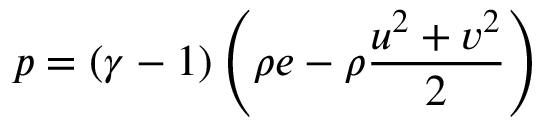Convert formula to latex. <formula><loc_0><loc_0><loc_500><loc_500>p = ( \gamma - 1 ) \left ( \rho e - \rho \frac { u ^ { 2 } + v ^ { 2 } } { 2 } \right )</formula> 